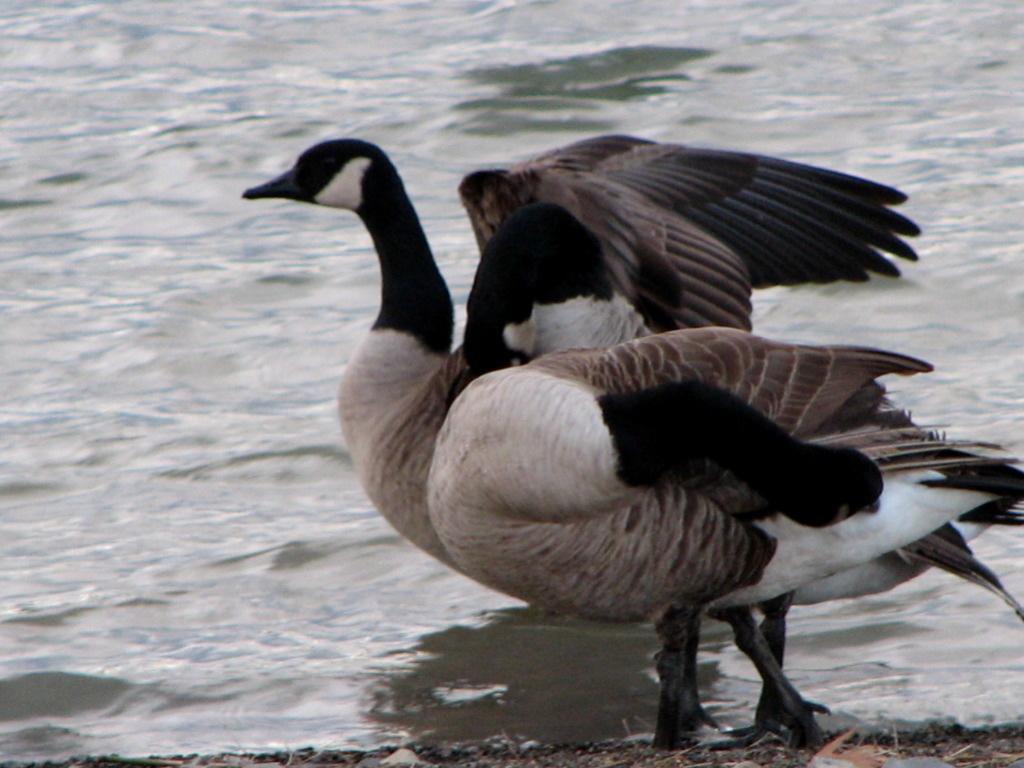Can you describe this image briefly? In this image in the center there are two birds, and at the bottom there is a river and some scrap. 